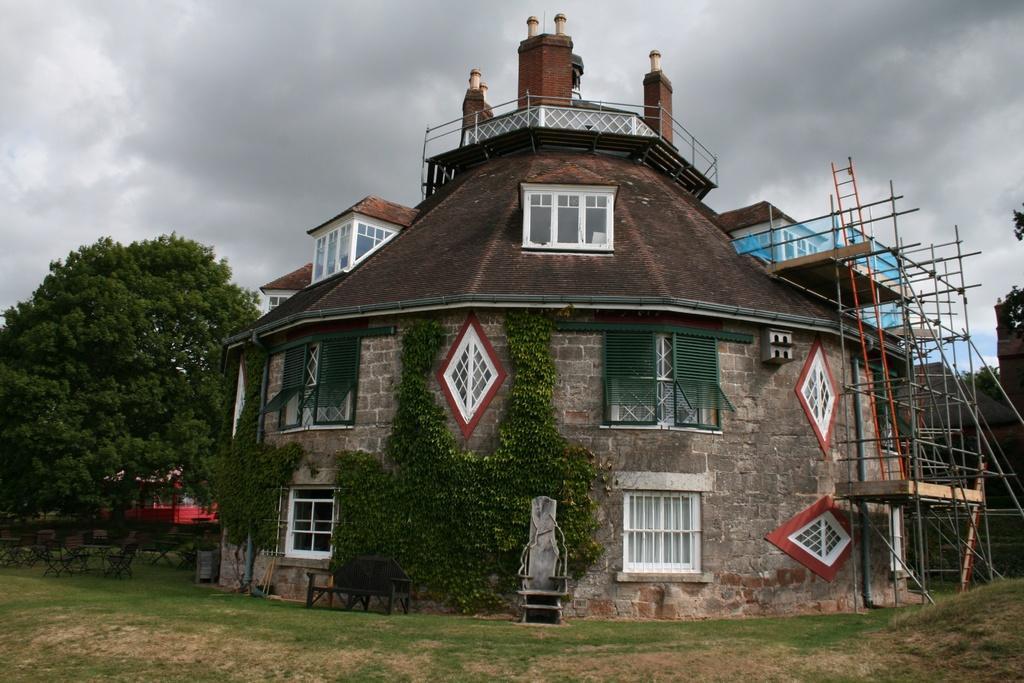Could you give a brief overview of what you see in this image? In this image in the center there is one building and there are some glass windows. On the right side there are some wooden poles, trees. On the left side also there are trees and building and chairs, at the bottom there is grass. At the top of the image there is sky. 